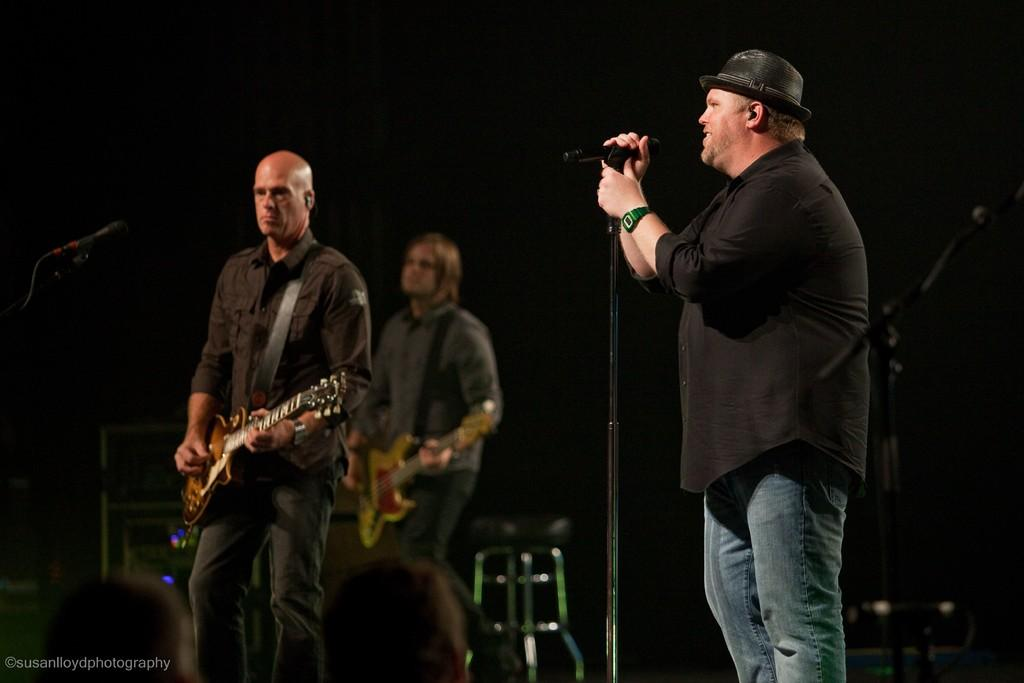How many people are in the image? There are three members in the image. What are two of the members doing? Two of them are holding guitars and playing them. What is the third member doing? The third member is singing. What is the singer holding? The singer is holding a microphone. Where are all the members standing? All members are standing on the floor. What type of oatmeal is being served on the bed in the image? There is no oatmeal or bed present in the image; it features three members, two of whom are playing guitars, one is singing, and all are standing on the floor. 